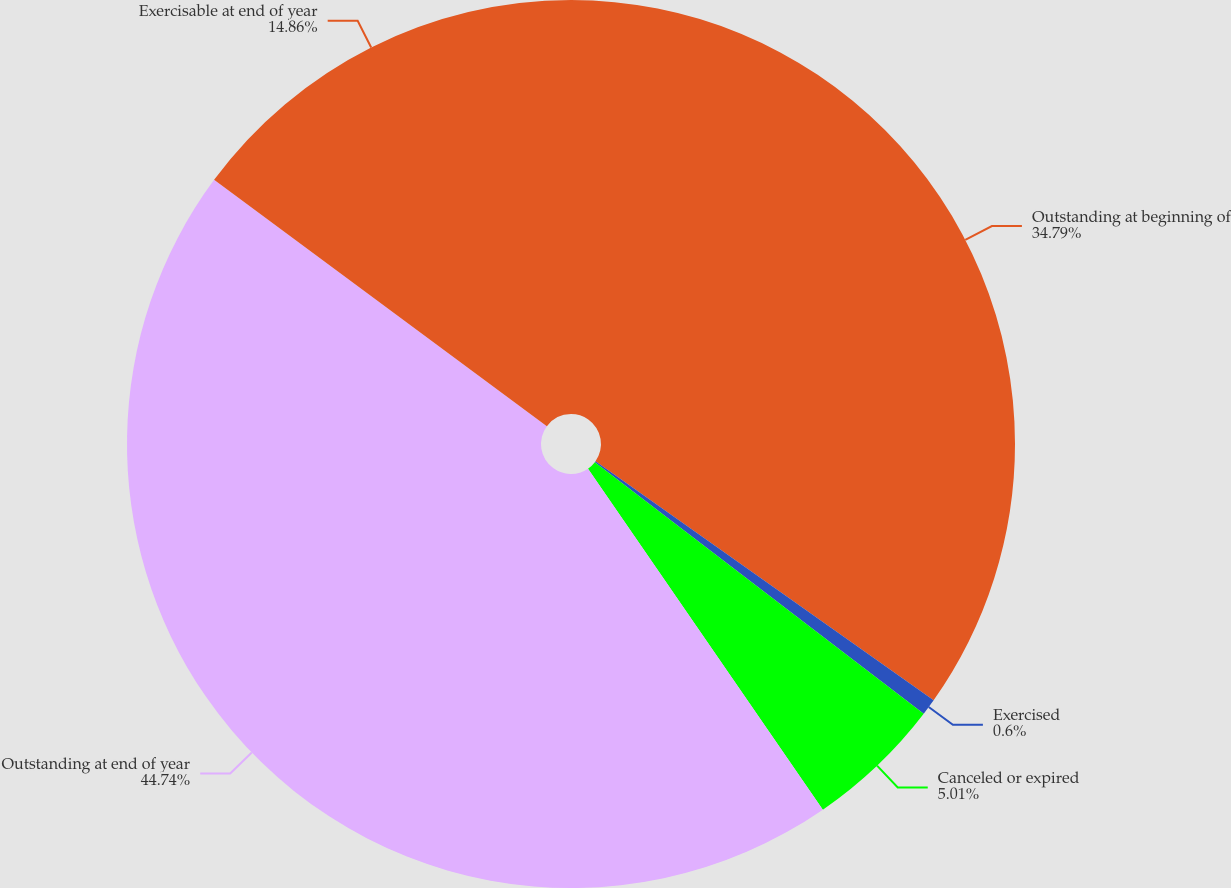<chart> <loc_0><loc_0><loc_500><loc_500><pie_chart><fcel>Outstanding at beginning of<fcel>Exercised<fcel>Canceled or expired<fcel>Outstanding at end of year<fcel>Exercisable at end of year<nl><fcel>34.79%<fcel>0.6%<fcel>5.01%<fcel>44.74%<fcel>14.86%<nl></chart> 